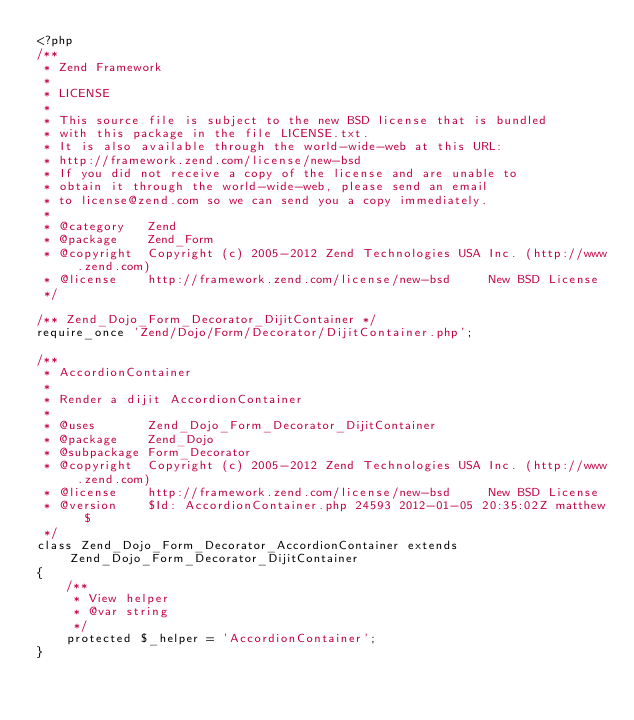<code> <loc_0><loc_0><loc_500><loc_500><_PHP_><?php
/**
 * Zend Framework
 *
 * LICENSE
 *
 * This source file is subject to the new BSD license that is bundled
 * with this package in the file LICENSE.txt.
 * It is also available through the world-wide-web at this URL:
 * http://framework.zend.com/license/new-bsd
 * If you did not receive a copy of the license and are unable to
 * obtain it through the world-wide-web, please send an email
 * to license@zend.com so we can send you a copy immediately.
 *
 * @category   Zend
 * @package    Zend_Form
 * @copyright  Copyright (c) 2005-2012 Zend Technologies USA Inc. (http://www.zend.com)
 * @license    http://framework.zend.com/license/new-bsd     New BSD License
 */

/** Zend_Dojo_Form_Decorator_DijitContainer */
require_once 'Zend/Dojo/Form/Decorator/DijitContainer.php';

/**
 * AccordionContainer
 *
 * Render a dijit AccordionContainer
 *
 * @uses       Zend_Dojo_Form_Decorator_DijitContainer
 * @package    Zend_Dojo
 * @subpackage Form_Decorator
 * @copyright  Copyright (c) 2005-2012 Zend Technologies USA Inc. (http://www.zend.com)
 * @license    http://framework.zend.com/license/new-bsd     New BSD License
 * @version    $Id: AccordionContainer.php 24593 2012-01-05 20:35:02Z matthew $
 */
class Zend_Dojo_Form_Decorator_AccordionContainer extends Zend_Dojo_Form_Decorator_DijitContainer
{
    /**
     * View helper
     * @var string
     */
    protected $_helper = 'AccordionContainer';
}
</code> 